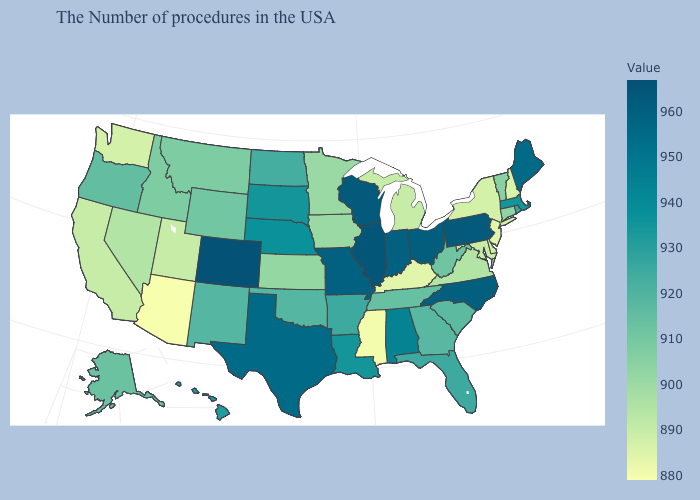Among the states that border New Hampshire , which have the lowest value?
Concise answer only. Vermont. Does Colorado have the highest value in the USA?
Keep it brief. Yes. Among the states that border New Hampshire , which have the highest value?
Answer briefly. Maine. Among the states that border Montana , which have the lowest value?
Concise answer only. Idaho. 